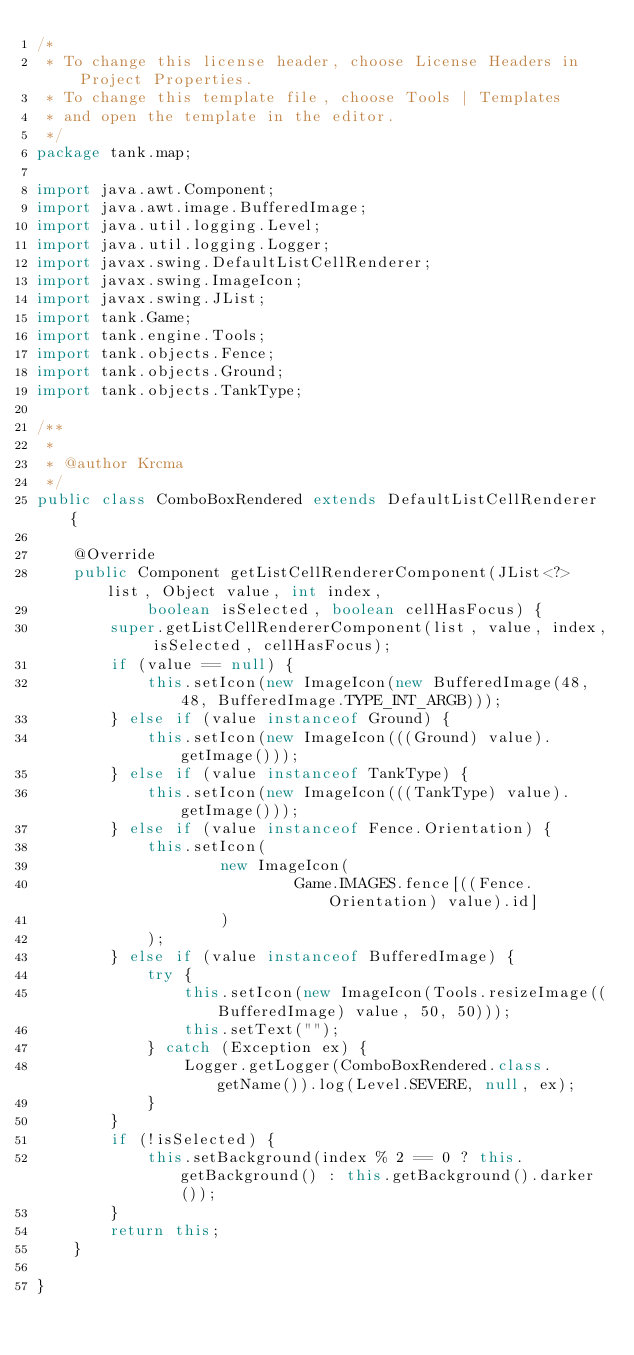Convert code to text. <code><loc_0><loc_0><loc_500><loc_500><_Java_>/*
 * To change this license header, choose License Headers in Project Properties.
 * To change this template file, choose Tools | Templates
 * and open the template in the editor.
 */
package tank.map;

import java.awt.Component;
import java.awt.image.BufferedImage;
import java.util.logging.Level;
import java.util.logging.Logger;
import javax.swing.DefaultListCellRenderer;
import javax.swing.ImageIcon;
import javax.swing.JList;
import tank.Game;
import tank.engine.Tools;
import tank.objects.Fence;
import tank.objects.Ground;
import tank.objects.TankType;

/**
 *
 * @author Krcma
 */
public class ComboBoxRendered extends DefaultListCellRenderer {

    @Override
    public Component getListCellRendererComponent(JList<?> list, Object value, int index,
            boolean isSelected, boolean cellHasFocus) {
        super.getListCellRendererComponent(list, value, index, isSelected, cellHasFocus);
        if (value == null) {
            this.setIcon(new ImageIcon(new BufferedImage(48, 48, BufferedImage.TYPE_INT_ARGB)));
        } else if (value instanceof Ground) {
            this.setIcon(new ImageIcon(((Ground) value).getImage()));
        } else if (value instanceof TankType) {
            this.setIcon(new ImageIcon(((TankType) value).getImage()));
        } else if (value instanceof Fence.Orientation) {
            this.setIcon(
                    new ImageIcon(
                            Game.IMAGES.fence[((Fence.Orientation) value).id]
                    )
            );
        } else if (value instanceof BufferedImage) {
            try {
                this.setIcon(new ImageIcon(Tools.resizeImage((BufferedImage) value, 50, 50)));
                this.setText("");
            } catch (Exception ex) {
                Logger.getLogger(ComboBoxRendered.class.getName()).log(Level.SEVERE, null, ex);
            }
        }
        if (!isSelected) {
            this.setBackground(index % 2 == 0 ? this.getBackground() : this.getBackground().darker());
        }
        return this;
    }

}
</code> 